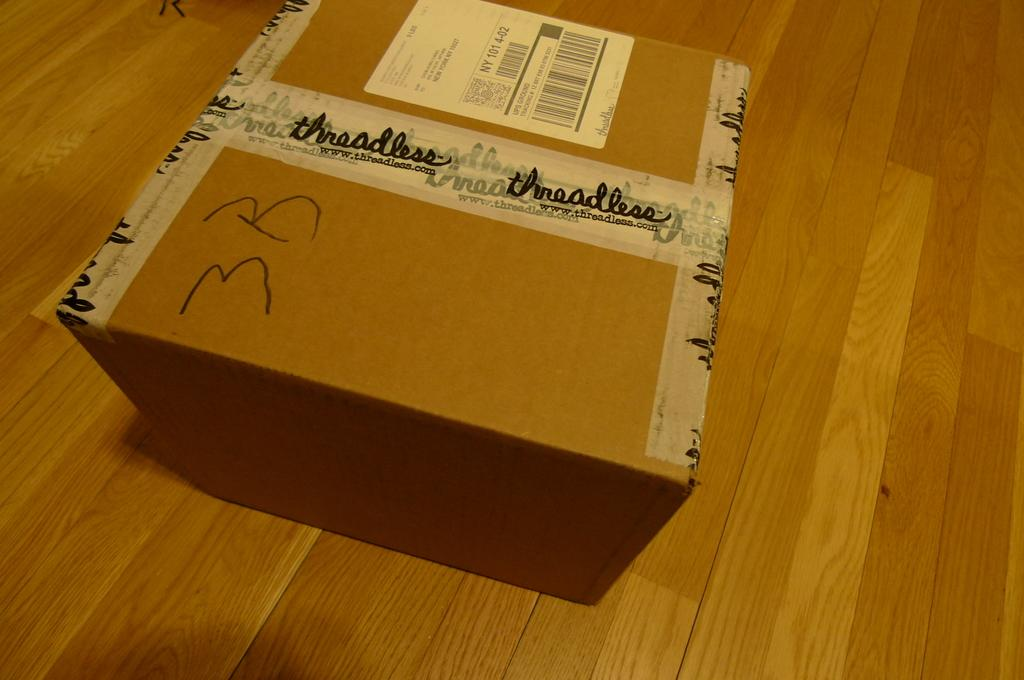<image>
Create a compact narrative representing the image presented. A cardboard box that has a shipping label and the words threadless on it. 